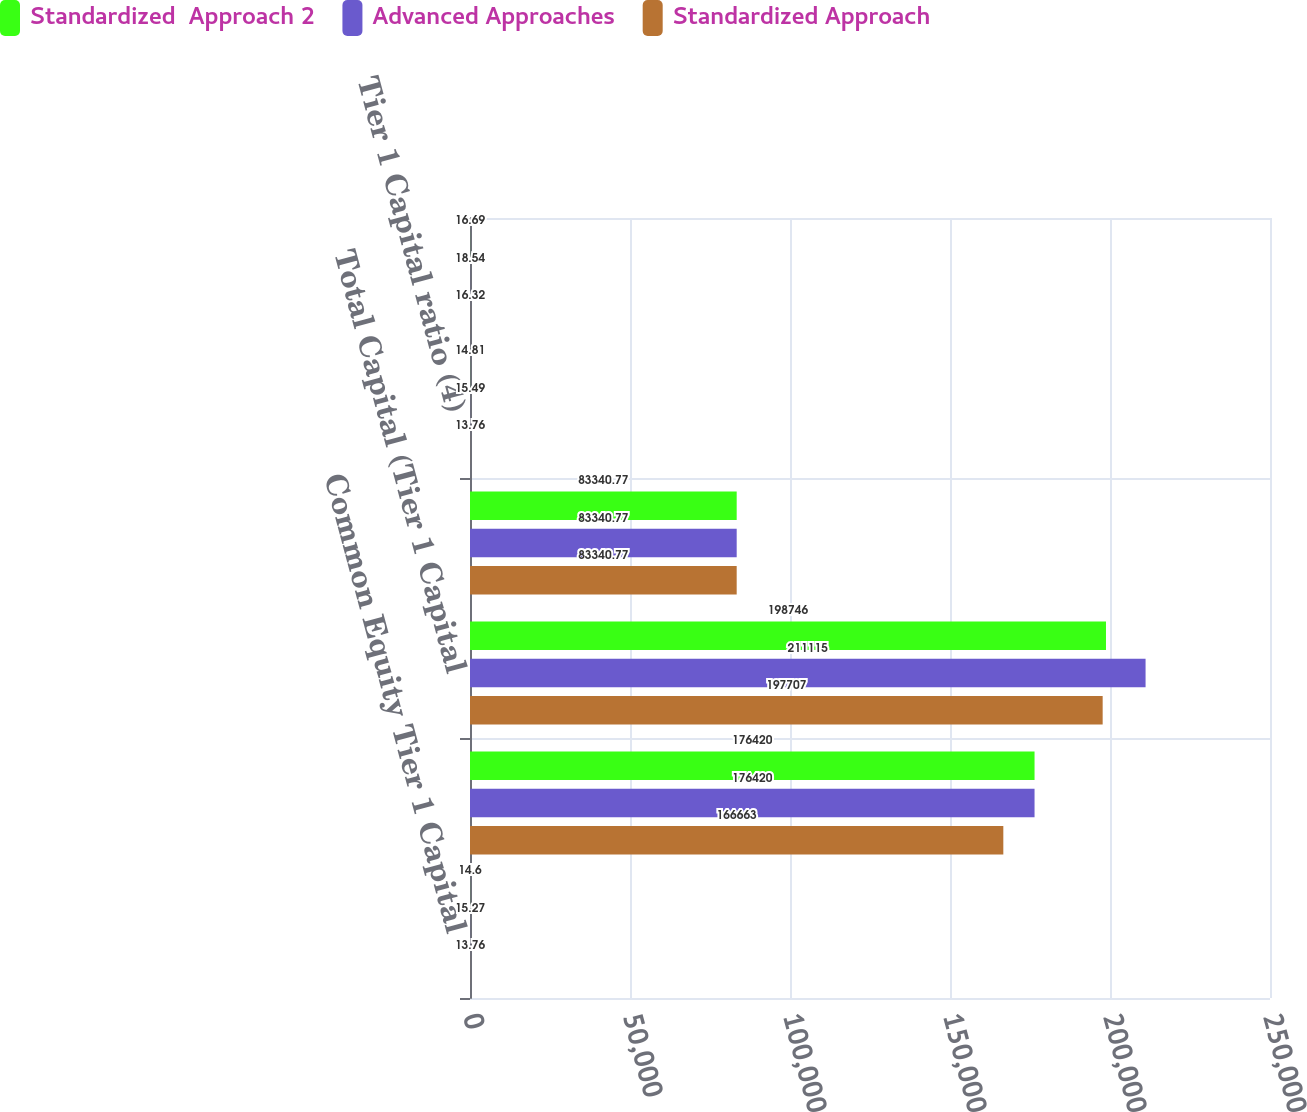<chart> <loc_0><loc_0><loc_500><loc_500><stacked_bar_chart><ecel><fcel>Common Equity Tier 1 Capital<fcel>Tier 1 Capital<fcel>Total Capital (Tier 1 Capital<fcel>Total Risk-Weighted Assets<fcel>Tier 1 Capital ratio (4)<fcel>Total Capital ratio (4)<nl><fcel>Standardized  Approach 2<fcel>14.6<fcel>176420<fcel>198746<fcel>83340.8<fcel>14.81<fcel>16.69<nl><fcel>Advanced Approaches<fcel>15.27<fcel>176420<fcel>211115<fcel>83340.8<fcel>15.49<fcel>18.54<nl><fcel>Standardized Approach<fcel>13.76<fcel>166663<fcel>197707<fcel>83340.8<fcel>13.76<fcel>16.32<nl></chart> 